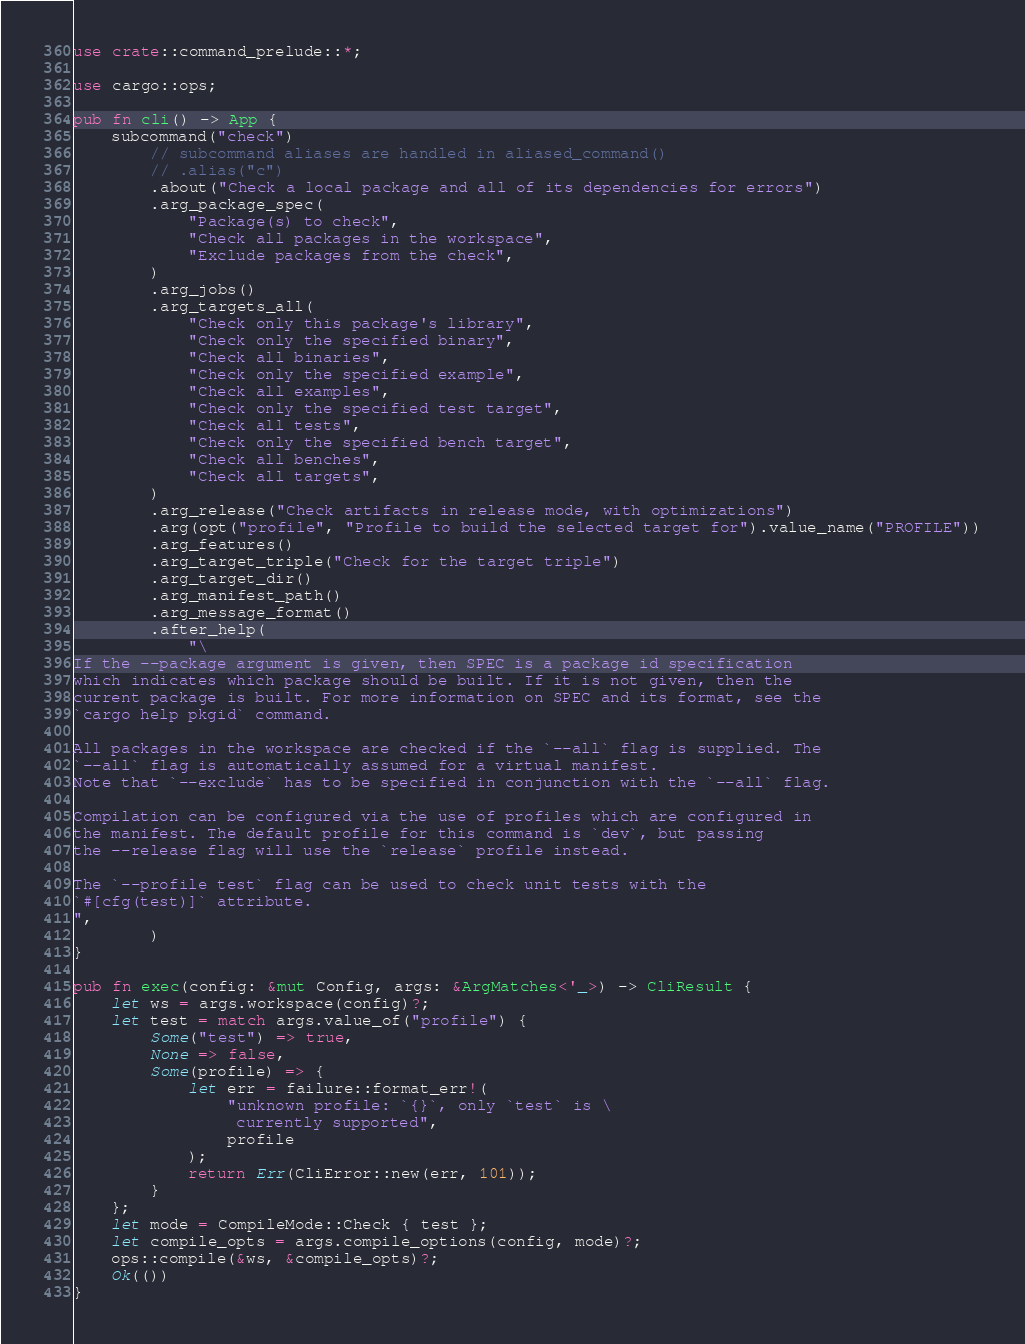<code> <loc_0><loc_0><loc_500><loc_500><_Rust_>use crate::command_prelude::*;

use cargo::ops;

pub fn cli() -> App {
    subcommand("check")
        // subcommand aliases are handled in aliased_command()
        // .alias("c")
        .about("Check a local package and all of its dependencies for errors")
        .arg_package_spec(
            "Package(s) to check",
            "Check all packages in the workspace",
            "Exclude packages from the check",
        )
        .arg_jobs()
        .arg_targets_all(
            "Check only this package's library",
            "Check only the specified binary",
            "Check all binaries",
            "Check only the specified example",
            "Check all examples",
            "Check only the specified test target",
            "Check all tests",
            "Check only the specified bench target",
            "Check all benches",
            "Check all targets",
        )
        .arg_release("Check artifacts in release mode, with optimizations")
        .arg(opt("profile", "Profile to build the selected target for").value_name("PROFILE"))
        .arg_features()
        .arg_target_triple("Check for the target triple")
        .arg_target_dir()
        .arg_manifest_path()
        .arg_message_format()
        .after_help(
            "\
If the --package argument is given, then SPEC is a package id specification
which indicates which package should be built. If it is not given, then the
current package is built. For more information on SPEC and its format, see the
`cargo help pkgid` command.

All packages in the workspace are checked if the `--all` flag is supplied. The
`--all` flag is automatically assumed for a virtual manifest.
Note that `--exclude` has to be specified in conjunction with the `--all` flag.

Compilation can be configured via the use of profiles which are configured in
the manifest. The default profile for this command is `dev`, but passing
the --release flag will use the `release` profile instead.

The `--profile test` flag can be used to check unit tests with the
`#[cfg(test)]` attribute.
",
        )
}

pub fn exec(config: &mut Config, args: &ArgMatches<'_>) -> CliResult {
    let ws = args.workspace(config)?;
    let test = match args.value_of("profile") {
        Some("test") => true,
        None => false,
        Some(profile) => {
            let err = failure::format_err!(
                "unknown profile: `{}`, only `test` is \
                 currently supported",
                profile
            );
            return Err(CliError::new(err, 101));
        }
    };
    let mode = CompileMode::Check { test };
    let compile_opts = args.compile_options(config, mode)?;
    ops::compile(&ws, &compile_opts)?;
    Ok(())
}
</code> 